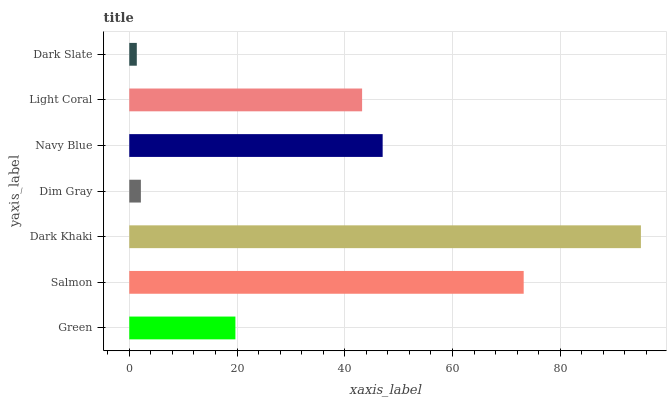Is Dark Slate the minimum?
Answer yes or no. Yes. Is Dark Khaki the maximum?
Answer yes or no. Yes. Is Salmon the minimum?
Answer yes or no. No. Is Salmon the maximum?
Answer yes or no. No. Is Salmon greater than Green?
Answer yes or no. Yes. Is Green less than Salmon?
Answer yes or no. Yes. Is Green greater than Salmon?
Answer yes or no. No. Is Salmon less than Green?
Answer yes or no. No. Is Light Coral the high median?
Answer yes or no. Yes. Is Light Coral the low median?
Answer yes or no. Yes. Is Navy Blue the high median?
Answer yes or no. No. Is Navy Blue the low median?
Answer yes or no. No. 